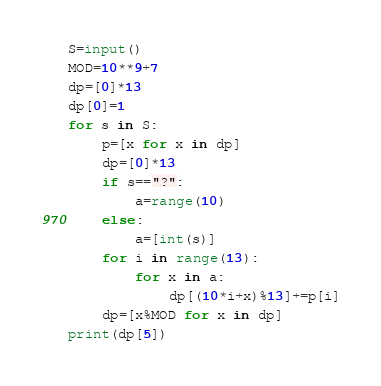<code> <loc_0><loc_0><loc_500><loc_500><_Python_>S=input()
MOD=10**9+7
dp=[0]*13
dp[0]=1
for s in S:
    p=[x for x in dp]
    dp=[0]*13
    if s=="?":
        a=range(10)
    else:
        a=[int(s)]
    for i in range(13):
        for x in a:
            dp[(10*i+x)%13]+=p[i]
    dp=[x%MOD for x in dp]
print(dp[5])</code> 